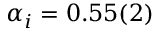Convert formula to latex. <formula><loc_0><loc_0><loc_500><loc_500>\alpha _ { i } = 0 . 5 5 ( 2 )</formula> 